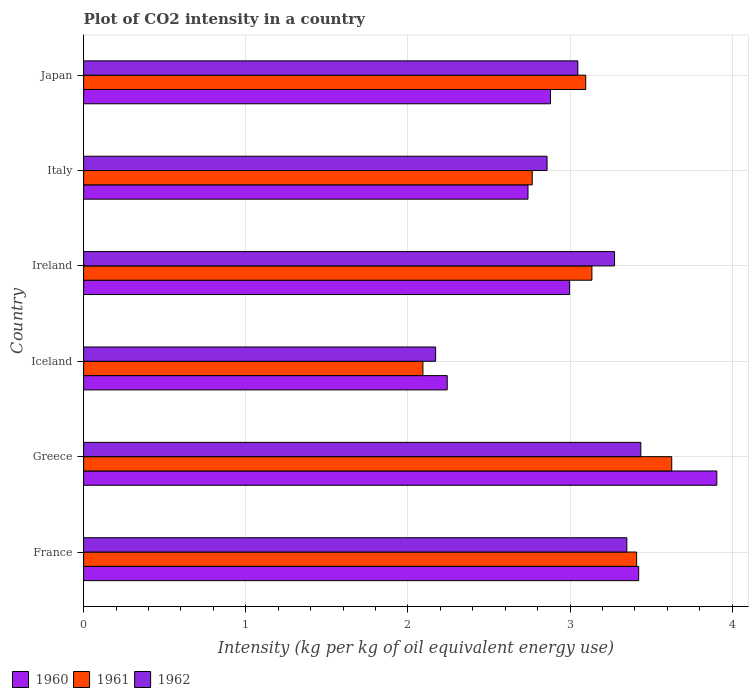How many different coloured bars are there?
Provide a succinct answer. 3. How many groups of bars are there?
Make the answer very short. 6. Are the number of bars per tick equal to the number of legend labels?
Your answer should be very brief. Yes. How many bars are there on the 1st tick from the top?
Keep it short and to the point. 3. What is the label of the 4th group of bars from the top?
Keep it short and to the point. Iceland. What is the CO2 intensity in in 1962 in France?
Offer a terse response. 3.35. Across all countries, what is the maximum CO2 intensity in in 1961?
Your answer should be very brief. 3.63. Across all countries, what is the minimum CO2 intensity in in 1962?
Offer a terse response. 2.17. In which country was the CO2 intensity in in 1961 minimum?
Your response must be concise. Iceland. What is the total CO2 intensity in in 1961 in the graph?
Provide a short and direct response. 18.13. What is the difference between the CO2 intensity in in 1961 in Ireland and that in Italy?
Your response must be concise. 0.37. What is the difference between the CO2 intensity in in 1961 in Greece and the CO2 intensity in in 1960 in Ireland?
Your response must be concise. 0.63. What is the average CO2 intensity in in 1961 per country?
Your response must be concise. 3.02. What is the difference between the CO2 intensity in in 1960 and CO2 intensity in in 1962 in France?
Offer a very short reply. 0.07. In how many countries, is the CO2 intensity in in 1960 greater than 1.4 kg?
Give a very brief answer. 6. What is the ratio of the CO2 intensity in in 1962 in Iceland to that in Japan?
Ensure brevity in your answer.  0.71. Is the CO2 intensity in in 1961 in Greece less than that in Japan?
Your answer should be compact. No. What is the difference between the highest and the second highest CO2 intensity in in 1962?
Your answer should be compact. 0.09. What is the difference between the highest and the lowest CO2 intensity in in 1962?
Offer a terse response. 1.27. What does the 3rd bar from the top in Ireland represents?
Make the answer very short. 1960. Is it the case that in every country, the sum of the CO2 intensity in in 1960 and CO2 intensity in in 1962 is greater than the CO2 intensity in in 1961?
Your answer should be compact. Yes. How many countries are there in the graph?
Your answer should be compact. 6. What is the difference between two consecutive major ticks on the X-axis?
Offer a terse response. 1. Are the values on the major ticks of X-axis written in scientific E-notation?
Make the answer very short. No. Does the graph contain grids?
Your answer should be very brief. Yes. How many legend labels are there?
Keep it short and to the point. 3. How are the legend labels stacked?
Make the answer very short. Horizontal. What is the title of the graph?
Provide a short and direct response. Plot of CO2 intensity in a country. Does "2013" appear as one of the legend labels in the graph?
Make the answer very short. No. What is the label or title of the X-axis?
Offer a terse response. Intensity (kg per kg of oil equivalent energy use). What is the Intensity (kg per kg of oil equivalent energy use) in 1960 in France?
Give a very brief answer. 3.42. What is the Intensity (kg per kg of oil equivalent energy use) of 1961 in France?
Make the answer very short. 3.41. What is the Intensity (kg per kg of oil equivalent energy use) in 1962 in France?
Your answer should be very brief. 3.35. What is the Intensity (kg per kg of oil equivalent energy use) in 1960 in Greece?
Offer a terse response. 3.91. What is the Intensity (kg per kg of oil equivalent energy use) of 1961 in Greece?
Make the answer very short. 3.63. What is the Intensity (kg per kg of oil equivalent energy use) of 1962 in Greece?
Offer a terse response. 3.44. What is the Intensity (kg per kg of oil equivalent energy use) in 1960 in Iceland?
Ensure brevity in your answer.  2.24. What is the Intensity (kg per kg of oil equivalent energy use) of 1961 in Iceland?
Keep it short and to the point. 2.09. What is the Intensity (kg per kg of oil equivalent energy use) in 1962 in Iceland?
Your response must be concise. 2.17. What is the Intensity (kg per kg of oil equivalent energy use) in 1960 in Ireland?
Ensure brevity in your answer.  3. What is the Intensity (kg per kg of oil equivalent energy use) of 1961 in Ireland?
Offer a terse response. 3.14. What is the Intensity (kg per kg of oil equivalent energy use) in 1962 in Ireland?
Provide a succinct answer. 3.27. What is the Intensity (kg per kg of oil equivalent energy use) of 1960 in Italy?
Make the answer very short. 2.74. What is the Intensity (kg per kg of oil equivalent energy use) of 1961 in Italy?
Your response must be concise. 2.77. What is the Intensity (kg per kg of oil equivalent energy use) in 1962 in Italy?
Give a very brief answer. 2.86. What is the Intensity (kg per kg of oil equivalent energy use) of 1960 in Japan?
Your answer should be very brief. 2.88. What is the Intensity (kg per kg of oil equivalent energy use) in 1961 in Japan?
Offer a very short reply. 3.1. What is the Intensity (kg per kg of oil equivalent energy use) in 1962 in Japan?
Give a very brief answer. 3.05. Across all countries, what is the maximum Intensity (kg per kg of oil equivalent energy use) of 1960?
Make the answer very short. 3.91. Across all countries, what is the maximum Intensity (kg per kg of oil equivalent energy use) of 1961?
Provide a short and direct response. 3.63. Across all countries, what is the maximum Intensity (kg per kg of oil equivalent energy use) of 1962?
Make the answer very short. 3.44. Across all countries, what is the minimum Intensity (kg per kg of oil equivalent energy use) of 1960?
Keep it short and to the point. 2.24. Across all countries, what is the minimum Intensity (kg per kg of oil equivalent energy use) in 1961?
Make the answer very short. 2.09. Across all countries, what is the minimum Intensity (kg per kg of oil equivalent energy use) of 1962?
Provide a succinct answer. 2.17. What is the total Intensity (kg per kg of oil equivalent energy use) in 1960 in the graph?
Your response must be concise. 18.19. What is the total Intensity (kg per kg of oil equivalent energy use) in 1961 in the graph?
Your response must be concise. 18.13. What is the total Intensity (kg per kg of oil equivalent energy use) of 1962 in the graph?
Provide a succinct answer. 18.14. What is the difference between the Intensity (kg per kg of oil equivalent energy use) of 1960 in France and that in Greece?
Give a very brief answer. -0.48. What is the difference between the Intensity (kg per kg of oil equivalent energy use) of 1961 in France and that in Greece?
Ensure brevity in your answer.  -0.22. What is the difference between the Intensity (kg per kg of oil equivalent energy use) in 1962 in France and that in Greece?
Provide a succinct answer. -0.09. What is the difference between the Intensity (kg per kg of oil equivalent energy use) of 1960 in France and that in Iceland?
Your answer should be compact. 1.18. What is the difference between the Intensity (kg per kg of oil equivalent energy use) of 1961 in France and that in Iceland?
Provide a succinct answer. 1.32. What is the difference between the Intensity (kg per kg of oil equivalent energy use) of 1962 in France and that in Iceland?
Provide a succinct answer. 1.18. What is the difference between the Intensity (kg per kg of oil equivalent energy use) in 1960 in France and that in Ireland?
Make the answer very short. 0.43. What is the difference between the Intensity (kg per kg of oil equivalent energy use) in 1961 in France and that in Ireland?
Your response must be concise. 0.28. What is the difference between the Intensity (kg per kg of oil equivalent energy use) of 1962 in France and that in Ireland?
Your response must be concise. 0.08. What is the difference between the Intensity (kg per kg of oil equivalent energy use) in 1960 in France and that in Italy?
Provide a succinct answer. 0.68. What is the difference between the Intensity (kg per kg of oil equivalent energy use) in 1961 in France and that in Italy?
Your response must be concise. 0.64. What is the difference between the Intensity (kg per kg of oil equivalent energy use) in 1962 in France and that in Italy?
Your answer should be very brief. 0.49. What is the difference between the Intensity (kg per kg of oil equivalent energy use) of 1960 in France and that in Japan?
Provide a short and direct response. 0.54. What is the difference between the Intensity (kg per kg of oil equivalent energy use) of 1961 in France and that in Japan?
Your answer should be very brief. 0.31. What is the difference between the Intensity (kg per kg of oil equivalent energy use) of 1962 in France and that in Japan?
Your answer should be compact. 0.3. What is the difference between the Intensity (kg per kg of oil equivalent energy use) of 1960 in Greece and that in Iceland?
Make the answer very short. 1.66. What is the difference between the Intensity (kg per kg of oil equivalent energy use) in 1961 in Greece and that in Iceland?
Make the answer very short. 1.53. What is the difference between the Intensity (kg per kg of oil equivalent energy use) in 1962 in Greece and that in Iceland?
Your response must be concise. 1.27. What is the difference between the Intensity (kg per kg of oil equivalent energy use) of 1960 in Greece and that in Ireland?
Offer a terse response. 0.91. What is the difference between the Intensity (kg per kg of oil equivalent energy use) in 1961 in Greece and that in Ireland?
Give a very brief answer. 0.49. What is the difference between the Intensity (kg per kg of oil equivalent energy use) of 1962 in Greece and that in Ireland?
Your answer should be compact. 0.16. What is the difference between the Intensity (kg per kg of oil equivalent energy use) in 1960 in Greece and that in Italy?
Make the answer very short. 1.16. What is the difference between the Intensity (kg per kg of oil equivalent energy use) of 1961 in Greece and that in Italy?
Ensure brevity in your answer.  0.86. What is the difference between the Intensity (kg per kg of oil equivalent energy use) of 1962 in Greece and that in Italy?
Ensure brevity in your answer.  0.58. What is the difference between the Intensity (kg per kg of oil equivalent energy use) of 1960 in Greece and that in Japan?
Keep it short and to the point. 1.03. What is the difference between the Intensity (kg per kg of oil equivalent energy use) in 1961 in Greece and that in Japan?
Offer a very short reply. 0.53. What is the difference between the Intensity (kg per kg of oil equivalent energy use) of 1962 in Greece and that in Japan?
Provide a succinct answer. 0.39. What is the difference between the Intensity (kg per kg of oil equivalent energy use) of 1960 in Iceland and that in Ireland?
Provide a short and direct response. -0.75. What is the difference between the Intensity (kg per kg of oil equivalent energy use) in 1961 in Iceland and that in Ireland?
Keep it short and to the point. -1.04. What is the difference between the Intensity (kg per kg of oil equivalent energy use) of 1962 in Iceland and that in Ireland?
Make the answer very short. -1.1. What is the difference between the Intensity (kg per kg of oil equivalent energy use) of 1960 in Iceland and that in Italy?
Your response must be concise. -0.5. What is the difference between the Intensity (kg per kg of oil equivalent energy use) in 1961 in Iceland and that in Italy?
Offer a terse response. -0.67. What is the difference between the Intensity (kg per kg of oil equivalent energy use) in 1962 in Iceland and that in Italy?
Your answer should be compact. -0.69. What is the difference between the Intensity (kg per kg of oil equivalent energy use) of 1960 in Iceland and that in Japan?
Provide a short and direct response. -0.64. What is the difference between the Intensity (kg per kg of oil equivalent energy use) in 1961 in Iceland and that in Japan?
Your answer should be compact. -1. What is the difference between the Intensity (kg per kg of oil equivalent energy use) of 1962 in Iceland and that in Japan?
Provide a succinct answer. -0.88. What is the difference between the Intensity (kg per kg of oil equivalent energy use) of 1960 in Ireland and that in Italy?
Keep it short and to the point. 0.26. What is the difference between the Intensity (kg per kg of oil equivalent energy use) of 1961 in Ireland and that in Italy?
Offer a very short reply. 0.37. What is the difference between the Intensity (kg per kg of oil equivalent energy use) in 1962 in Ireland and that in Italy?
Your answer should be compact. 0.42. What is the difference between the Intensity (kg per kg of oil equivalent energy use) of 1960 in Ireland and that in Japan?
Your response must be concise. 0.12. What is the difference between the Intensity (kg per kg of oil equivalent energy use) in 1961 in Ireland and that in Japan?
Provide a short and direct response. 0.04. What is the difference between the Intensity (kg per kg of oil equivalent energy use) of 1962 in Ireland and that in Japan?
Provide a succinct answer. 0.23. What is the difference between the Intensity (kg per kg of oil equivalent energy use) in 1960 in Italy and that in Japan?
Offer a very short reply. -0.14. What is the difference between the Intensity (kg per kg of oil equivalent energy use) in 1961 in Italy and that in Japan?
Your response must be concise. -0.33. What is the difference between the Intensity (kg per kg of oil equivalent energy use) in 1962 in Italy and that in Japan?
Make the answer very short. -0.19. What is the difference between the Intensity (kg per kg of oil equivalent energy use) of 1960 in France and the Intensity (kg per kg of oil equivalent energy use) of 1961 in Greece?
Provide a short and direct response. -0.2. What is the difference between the Intensity (kg per kg of oil equivalent energy use) in 1960 in France and the Intensity (kg per kg of oil equivalent energy use) in 1962 in Greece?
Ensure brevity in your answer.  -0.01. What is the difference between the Intensity (kg per kg of oil equivalent energy use) of 1961 in France and the Intensity (kg per kg of oil equivalent energy use) of 1962 in Greece?
Your answer should be very brief. -0.03. What is the difference between the Intensity (kg per kg of oil equivalent energy use) in 1960 in France and the Intensity (kg per kg of oil equivalent energy use) in 1961 in Iceland?
Your answer should be compact. 1.33. What is the difference between the Intensity (kg per kg of oil equivalent energy use) of 1960 in France and the Intensity (kg per kg of oil equivalent energy use) of 1962 in Iceland?
Offer a very short reply. 1.25. What is the difference between the Intensity (kg per kg of oil equivalent energy use) of 1961 in France and the Intensity (kg per kg of oil equivalent energy use) of 1962 in Iceland?
Offer a very short reply. 1.24. What is the difference between the Intensity (kg per kg of oil equivalent energy use) of 1960 in France and the Intensity (kg per kg of oil equivalent energy use) of 1961 in Ireland?
Your answer should be compact. 0.29. What is the difference between the Intensity (kg per kg of oil equivalent energy use) of 1960 in France and the Intensity (kg per kg of oil equivalent energy use) of 1962 in Ireland?
Your response must be concise. 0.15. What is the difference between the Intensity (kg per kg of oil equivalent energy use) in 1961 in France and the Intensity (kg per kg of oil equivalent energy use) in 1962 in Ireland?
Ensure brevity in your answer.  0.14. What is the difference between the Intensity (kg per kg of oil equivalent energy use) in 1960 in France and the Intensity (kg per kg of oil equivalent energy use) in 1961 in Italy?
Keep it short and to the point. 0.66. What is the difference between the Intensity (kg per kg of oil equivalent energy use) of 1960 in France and the Intensity (kg per kg of oil equivalent energy use) of 1962 in Italy?
Give a very brief answer. 0.57. What is the difference between the Intensity (kg per kg of oil equivalent energy use) in 1961 in France and the Intensity (kg per kg of oil equivalent energy use) in 1962 in Italy?
Give a very brief answer. 0.55. What is the difference between the Intensity (kg per kg of oil equivalent energy use) in 1960 in France and the Intensity (kg per kg of oil equivalent energy use) in 1961 in Japan?
Keep it short and to the point. 0.33. What is the difference between the Intensity (kg per kg of oil equivalent energy use) of 1960 in France and the Intensity (kg per kg of oil equivalent energy use) of 1962 in Japan?
Give a very brief answer. 0.38. What is the difference between the Intensity (kg per kg of oil equivalent energy use) of 1961 in France and the Intensity (kg per kg of oil equivalent energy use) of 1962 in Japan?
Keep it short and to the point. 0.36. What is the difference between the Intensity (kg per kg of oil equivalent energy use) of 1960 in Greece and the Intensity (kg per kg of oil equivalent energy use) of 1961 in Iceland?
Make the answer very short. 1.81. What is the difference between the Intensity (kg per kg of oil equivalent energy use) of 1960 in Greece and the Intensity (kg per kg of oil equivalent energy use) of 1962 in Iceland?
Offer a terse response. 1.73. What is the difference between the Intensity (kg per kg of oil equivalent energy use) in 1961 in Greece and the Intensity (kg per kg of oil equivalent energy use) in 1962 in Iceland?
Ensure brevity in your answer.  1.46. What is the difference between the Intensity (kg per kg of oil equivalent energy use) of 1960 in Greece and the Intensity (kg per kg of oil equivalent energy use) of 1961 in Ireland?
Your response must be concise. 0.77. What is the difference between the Intensity (kg per kg of oil equivalent energy use) of 1960 in Greece and the Intensity (kg per kg of oil equivalent energy use) of 1962 in Ireland?
Offer a very short reply. 0.63. What is the difference between the Intensity (kg per kg of oil equivalent energy use) in 1961 in Greece and the Intensity (kg per kg of oil equivalent energy use) in 1962 in Ireland?
Your response must be concise. 0.35. What is the difference between the Intensity (kg per kg of oil equivalent energy use) in 1960 in Greece and the Intensity (kg per kg of oil equivalent energy use) in 1961 in Italy?
Your answer should be very brief. 1.14. What is the difference between the Intensity (kg per kg of oil equivalent energy use) of 1960 in Greece and the Intensity (kg per kg of oil equivalent energy use) of 1962 in Italy?
Provide a succinct answer. 1.05. What is the difference between the Intensity (kg per kg of oil equivalent energy use) of 1961 in Greece and the Intensity (kg per kg of oil equivalent energy use) of 1962 in Italy?
Keep it short and to the point. 0.77. What is the difference between the Intensity (kg per kg of oil equivalent energy use) in 1960 in Greece and the Intensity (kg per kg of oil equivalent energy use) in 1961 in Japan?
Ensure brevity in your answer.  0.81. What is the difference between the Intensity (kg per kg of oil equivalent energy use) in 1960 in Greece and the Intensity (kg per kg of oil equivalent energy use) in 1962 in Japan?
Keep it short and to the point. 0.86. What is the difference between the Intensity (kg per kg of oil equivalent energy use) in 1961 in Greece and the Intensity (kg per kg of oil equivalent energy use) in 1962 in Japan?
Offer a terse response. 0.58. What is the difference between the Intensity (kg per kg of oil equivalent energy use) of 1960 in Iceland and the Intensity (kg per kg of oil equivalent energy use) of 1961 in Ireland?
Ensure brevity in your answer.  -0.89. What is the difference between the Intensity (kg per kg of oil equivalent energy use) in 1960 in Iceland and the Intensity (kg per kg of oil equivalent energy use) in 1962 in Ireland?
Keep it short and to the point. -1.03. What is the difference between the Intensity (kg per kg of oil equivalent energy use) in 1961 in Iceland and the Intensity (kg per kg of oil equivalent energy use) in 1962 in Ireland?
Offer a very short reply. -1.18. What is the difference between the Intensity (kg per kg of oil equivalent energy use) in 1960 in Iceland and the Intensity (kg per kg of oil equivalent energy use) in 1961 in Italy?
Your answer should be very brief. -0.52. What is the difference between the Intensity (kg per kg of oil equivalent energy use) in 1960 in Iceland and the Intensity (kg per kg of oil equivalent energy use) in 1962 in Italy?
Offer a terse response. -0.62. What is the difference between the Intensity (kg per kg of oil equivalent energy use) of 1961 in Iceland and the Intensity (kg per kg of oil equivalent energy use) of 1962 in Italy?
Offer a very short reply. -0.77. What is the difference between the Intensity (kg per kg of oil equivalent energy use) of 1960 in Iceland and the Intensity (kg per kg of oil equivalent energy use) of 1961 in Japan?
Offer a terse response. -0.85. What is the difference between the Intensity (kg per kg of oil equivalent energy use) in 1960 in Iceland and the Intensity (kg per kg of oil equivalent energy use) in 1962 in Japan?
Your answer should be compact. -0.81. What is the difference between the Intensity (kg per kg of oil equivalent energy use) of 1961 in Iceland and the Intensity (kg per kg of oil equivalent energy use) of 1962 in Japan?
Provide a succinct answer. -0.96. What is the difference between the Intensity (kg per kg of oil equivalent energy use) of 1960 in Ireland and the Intensity (kg per kg of oil equivalent energy use) of 1961 in Italy?
Provide a short and direct response. 0.23. What is the difference between the Intensity (kg per kg of oil equivalent energy use) of 1960 in Ireland and the Intensity (kg per kg of oil equivalent energy use) of 1962 in Italy?
Provide a short and direct response. 0.14. What is the difference between the Intensity (kg per kg of oil equivalent energy use) in 1961 in Ireland and the Intensity (kg per kg of oil equivalent energy use) in 1962 in Italy?
Provide a short and direct response. 0.28. What is the difference between the Intensity (kg per kg of oil equivalent energy use) of 1960 in Ireland and the Intensity (kg per kg of oil equivalent energy use) of 1961 in Japan?
Your response must be concise. -0.1. What is the difference between the Intensity (kg per kg of oil equivalent energy use) in 1960 in Ireland and the Intensity (kg per kg of oil equivalent energy use) in 1962 in Japan?
Offer a very short reply. -0.05. What is the difference between the Intensity (kg per kg of oil equivalent energy use) in 1961 in Ireland and the Intensity (kg per kg of oil equivalent energy use) in 1962 in Japan?
Your answer should be compact. 0.09. What is the difference between the Intensity (kg per kg of oil equivalent energy use) in 1960 in Italy and the Intensity (kg per kg of oil equivalent energy use) in 1961 in Japan?
Make the answer very short. -0.36. What is the difference between the Intensity (kg per kg of oil equivalent energy use) of 1960 in Italy and the Intensity (kg per kg of oil equivalent energy use) of 1962 in Japan?
Your answer should be compact. -0.31. What is the difference between the Intensity (kg per kg of oil equivalent energy use) in 1961 in Italy and the Intensity (kg per kg of oil equivalent energy use) in 1962 in Japan?
Offer a terse response. -0.28. What is the average Intensity (kg per kg of oil equivalent energy use) in 1960 per country?
Make the answer very short. 3.03. What is the average Intensity (kg per kg of oil equivalent energy use) of 1961 per country?
Your answer should be very brief. 3.02. What is the average Intensity (kg per kg of oil equivalent energy use) of 1962 per country?
Your answer should be very brief. 3.02. What is the difference between the Intensity (kg per kg of oil equivalent energy use) of 1960 and Intensity (kg per kg of oil equivalent energy use) of 1961 in France?
Keep it short and to the point. 0.01. What is the difference between the Intensity (kg per kg of oil equivalent energy use) in 1960 and Intensity (kg per kg of oil equivalent energy use) in 1962 in France?
Provide a short and direct response. 0.07. What is the difference between the Intensity (kg per kg of oil equivalent energy use) of 1961 and Intensity (kg per kg of oil equivalent energy use) of 1962 in France?
Provide a succinct answer. 0.06. What is the difference between the Intensity (kg per kg of oil equivalent energy use) in 1960 and Intensity (kg per kg of oil equivalent energy use) in 1961 in Greece?
Give a very brief answer. 0.28. What is the difference between the Intensity (kg per kg of oil equivalent energy use) of 1960 and Intensity (kg per kg of oil equivalent energy use) of 1962 in Greece?
Your response must be concise. 0.47. What is the difference between the Intensity (kg per kg of oil equivalent energy use) of 1961 and Intensity (kg per kg of oil equivalent energy use) of 1962 in Greece?
Your answer should be very brief. 0.19. What is the difference between the Intensity (kg per kg of oil equivalent energy use) in 1960 and Intensity (kg per kg of oil equivalent energy use) in 1961 in Iceland?
Your answer should be very brief. 0.15. What is the difference between the Intensity (kg per kg of oil equivalent energy use) of 1960 and Intensity (kg per kg of oil equivalent energy use) of 1962 in Iceland?
Ensure brevity in your answer.  0.07. What is the difference between the Intensity (kg per kg of oil equivalent energy use) in 1961 and Intensity (kg per kg of oil equivalent energy use) in 1962 in Iceland?
Offer a terse response. -0.08. What is the difference between the Intensity (kg per kg of oil equivalent energy use) of 1960 and Intensity (kg per kg of oil equivalent energy use) of 1961 in Ireland?
Your answer should be very brief. -0.14. What is the difference between the Intensity (kg per kg of oil equivalent energy use) in 1960 and Intensity (kg per kg of oil equivalent energy use) in 1962 in Ireland?
Make the answer very short. -0.28. What is the difference between the Intensity (kg per kg of oil equivalent energy use) in 1961 and Intensity (kg per kg of oil equivalent energy use) in 1962 in Ireland?
Offer a very short reply. -0.14. What is the difference between the Intensity (kg per kg of oil equivalent energy use) of 1960 and Intensity (kg per kg of oil equivalent energy use) of 1961 in Italy?
Your answer should be compact. -0.03. What is the difference between the Intensity (kg per kg of oil equivalent energy use) of 1960 and Intensity (kg per kg of oil equivalent energy use) of 1962 in Italy?
Provide a short and direct response. -0.12. What is the difference between the Intensity (kg per kg of oil equivalent energy use) in 1961 and Intensity (kg per kg of oil equivalent energy use) in 1962 in Italy?
Give a very brief answer. -0.09. What is the difference between the Intensity (kg per kg of oil equivalent energy use) in 1960 and Intensity (kg per kg of oil equivalent energy use) in 1961 in Japan?
Make the answer very short. -0.22. What is the difference between the Intensity (kg per kg of oil equivalent energy use) in 1960 and Intensity (kg per kg of oil equivalent energy use) in 1962 in Japan?
Make the answer very short. -0.17. What is the difference between the Intensity (kg per kg of oil equivalent energy use) in 1961 and Intensity (kg per kg of oil equivalent energy use) in 1962 in Japan?
Give a very brief answer. 0.05. What is the ratio of the Intensity (kg per kg of oil equivalent energy use) of 1960 in France to that in Greece?
Offer a very short reply. 0.88. What is the ratio of the Intensity (kg per kg of oil equivalent energy use) of 1961 in France to that in Greece?
Provide a succinct answer. 0.94. What is the ratio of the Intensity (kg per kg of oil equivalent energy use) in 1962 in France to that in Greece?
Your answer should be very brief. 0.97. What is the ratio of the Intensity (kg per kg of oil equivalent energy use) of 1960 in France to that in Iceland?
Your answer should be very brief. 1.53. What is the ratio of the Intensity (kg per kg of oil equivalent energy use) of 1961 in France to that in Iceland?
Give a very brief answer. 1.63. What is the ratio of the Intensity (kg per kg of oil equivalent energy use) of 1962 in France to that in Iceland?
Your answer should be very brief. 1.54. What is the ratio of the Intensity (kg per kg of oil equivalent energy use) in 1960 in France to that in Ireland?
Keep it short and to the point. 1.14. What is the ratio of the Intensity (kg per kg of oil equivalent energy use) of 1961 in France to that in Ireland?
Provide a short and direct response. 1.09. What is the ratio of the Intensity (kg per kg of oil equivalent energy use) in 1962 in France to that in Ireland?
Give a very brief answer. 1.02. What is the ratio of the Intensity (kg per kg of oil equivalent energy use) in 1960 in France to that in Italy?
Give a very brief answer. 1.25. What is the ratio of the Intensity (kg per kg of oil equivalent energy use) of 1961 in France to that in Italy?
Give a very brief answer. 1.23. What is the ratio of the Intensity (kg per kg of oil equivalent energy use) of 1962 in France to that in Italy?
Ensure brevity in your answer.  1.17. What is the ratio of the Intensity (kg per kg of oil equivalent energy use) in 1960 in France to that in Japan?
Provide a succinct answer. 1.19. What is the ratio of the Intensity (kg per kg of oil equivalent energy use) of 1961 in France to that in Japan?
Your answer should be very brief. 1.1. What is the ratio of the Intensity (kg per kg of oil equivalent energy use) in 1962 in France to that in Japan?
Your answer should be compact. 1.1. What is the ratio of the Intensity (kg per kg of oil equivalent energy use) of 1960 in Greece to that in Iceland?
Offer a terse response. 1.74. What is the ratio of the Intensity (kg per kg of oil equivalent energy use) of 1961 in Greece to that in Iceland?
Your response must be concise. 1.73. What is the ratio of the Intensity (kg per kg of oil equivalent energy use) of 1962 in Greece to that in Iceland?
Make the answer very short. 1.58. What is the ratio of the Intensity (kg per kg of oil equivalent energy use) in 1960 in Greece to that in Ireland?
Keep it short and to the point. 1.3. What is the ratio of the Intensity (kg per kg of oil equivalent energy use) in 1961 in Greece to that in Ireland?
Provide a succinct answer. 1.16. What is the ratio of the Intensity (kg per kg of oil equivalent energy use) of 1962 in Greece to that in Ireland?
Your answer should be very brief. 1.05. What is the ratio of the Intensity (kg per kg of oil equivalent energy use) of 1960 in Greece to that in Italy?
Your response must be concise. 1.43. What is the ratio of the Intensity (kg per kg of oil equivalent energy use) in 1961 in Greece to that in Italy?
Make the answer very short. 1.31. What is the ratio of the Intensity (kg per kg of oil equivalent energy use) in 1962 in Greece to that in Italy?
Your answer should be very brief. 1.2. What is the ratio of the Intensity (kg per kg of oil equivalent energy use) in 1960 in Greece to that in Japan?
Ensure brevity in your answer.  1.36. What is the ratio of the Intensity (kg per kg of oil equivalent energy use) in 1961 in Greece to that in Japan?
Your response must be concise. 1.17. What is the ratio of the Intensity (kg per kg of oil equivalent energy use) of 1962 in Greece to that in Japan?
Make the answer very short. 1.13. What is the ratio of the Intensity (kg per kg of oil equivalent energy use) of 1960 in Iceland to that in Ireland?
Make the answer very short. 0.75. What is the ratio of the Intensity (kg per kg of oil equivalent energy use) of 1961 in Iceland to that in Ireland?
Keep it short and to the point. 0.67. What is the ratio of the Intensity (kg per kg of oil equivalent energy use) in 1962 in Iceland to that in Ireland?
Give a very brief answer. 0.66. What is the ratio of the Intensity (kg per kg of oil equivalent energy use) in 1960 in Iceland to that in Italy?
Provide a succinct answer. 0.82. What is the ratio of the Intensity (kg per kg of oil equivalent energy use) of 1961 in Iceland to that in Italy?
Your response must be concise. 0.76. What is the ratio of the Intensity (kg per kg of oil equivalent energy use) of 1962 in Iceland to that in Italy?
Provide a succinct answer. 0.76. What is the ratio of the Intensity (kg per kg of oil equivalent energy use) in 1960 in Iceland to that in Japan?
Give a very brief answer. 0.78. What is the ratio of the Intensity (kg per kg of oil equivalent energy use) in 1961 in Iceland to that in Japan?
Your answer should be very brief. 0.68. What is the ratio of the Intensity (kg per kg of oil equivalent energy use) of 1962 in Iceland to that in Japan?
Provide a succinct answer. 0.71. What is the ratio of the Intensity (kg per kg of oil equivalent energy use) in 1960 in Ireland to that in Italy?
Provide a short and direct response. 1.09. What is the ratio of the Intensity (kg per kg of oil equivalent energy use) of 1961 in Ireland to that in Italy?
Offer a very short reply. 1.13. What is the ratio of the Intensity (kg per kg of oil equivalent energy use) in 1962 in Ireland to that in Italy?
Your response must be concise. 1.15. What is the ratio of the Intensity (kg per kg of oil equivalent energy use) of 1960 in Ireland to that in Japan?
Your answer should be very brief. 1.04. What is the ratio of the Intensity (kg per kg of oil equivalent energy use) in 1961 in Ireland to that in Japan?
Ensure brevity in your answer.  1.01. What is the ratio of the Intensity (kg per kg of oil equivalent energy use) of 1962 in Ireland to that in Japan?
Make the answer very short. 1.07. What is the ratio of the Intensity (kg per kg of oil equivalent energy use) of 1960 in Italy to that in Japan?
Offer a very short reply. 0.95. What is the ratio of the Intensity (kg per kg of oil equivalent energy use) in 1961 in Italy to that in Japan?
Ensure brevity in your answer.  0.89. What is the ratio of the Intensity (kg per kg of oil equivalent energy use) of 1962 in Italy to that in Japan?
Your answer should be compact. 0.94. What is the difference between the highest and the second highest Intensity (kg per kg of oil equivalent energy use) in 1960?
Offer a terse response. 0.48. What is the difference between the highest and the second highest Intensity (kg per kg of oil equivalent energy use) in 1961?
Your answer should be very brief. 0.22. What is the difference between the highest and the second highest Intensity (kg per kg of oil equivalent energy use) of 1962?
Give a very brief answer. 0.09. What is the difference between the highest and the lowest Intensity (kg per kg of oil equivalent energy use) in 1960?
Provide a short and direct response. 1.66. What is the difference between the highest and the lowest Intensity (kg per kg of oil equivalent energy use) of 1961?
Your response must be concise. 1.53. What is the difference between the highest and the lowest Intensity (kg per kg of oil equivalent energy use) of 1962?
Offer a very short reply. 1.27. 